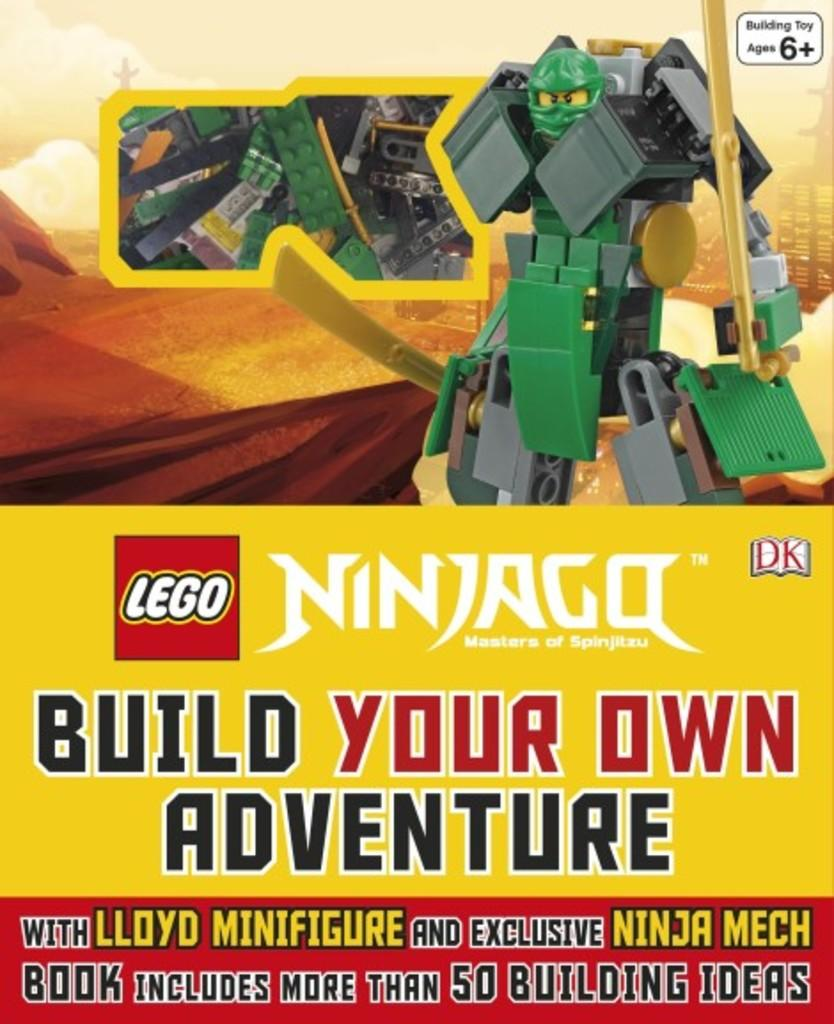<image>
Provide a brief description of the given image. A Ninjago build your own adventure set from Lego shows a warrior character on the front. 